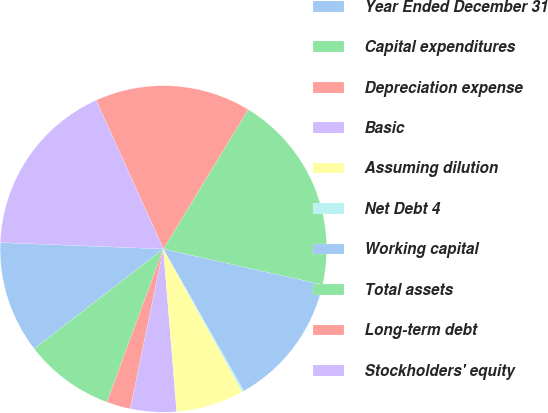<chart> <loc_0><loc_0><loc_500><loc_500><pie_chart><fcel>Year Ended December 31<fcel>Capital expenditures<fcel>Depreciation expense<fcel>Basic<fcel>Assuming dilution<fcel>Net Debt 4<fcel>Working capital<fcel>Total assets<fcel>Long-term debt<fcel>Stockholders' equity<nl><fcel>11.09%<fcel>8.91%<fcel>2.37%<fcel>4.55%<fcel>6.73%<fcel>0.19%<fcel>13.27%<fcel>19.81%<fcel>15.45%<fcel>17.63%<nl></chart> 